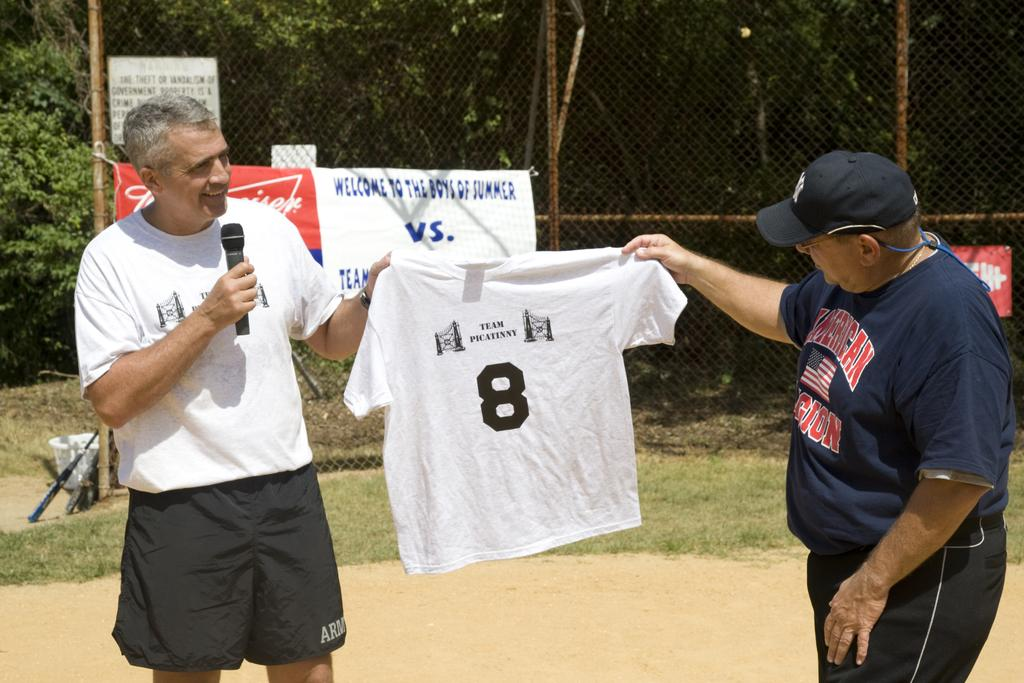Provide a one-sentence caption for the provided image. An elderly man in an American Legion shirt holds up another shirt with another man. 